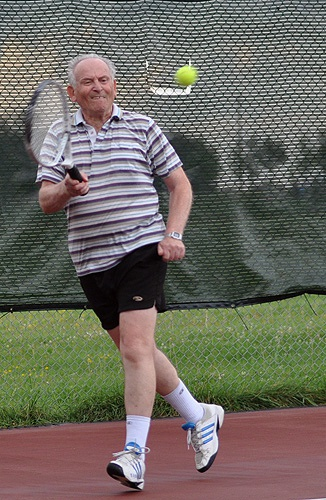Describe the objects in this image and their specific colors. I can see people in black, darkgray, lavender, and gray tones, tennis racket in black, darkgray, gray, and lightgray tones, and sports ball in black, khaki, and olive tones in this image. 